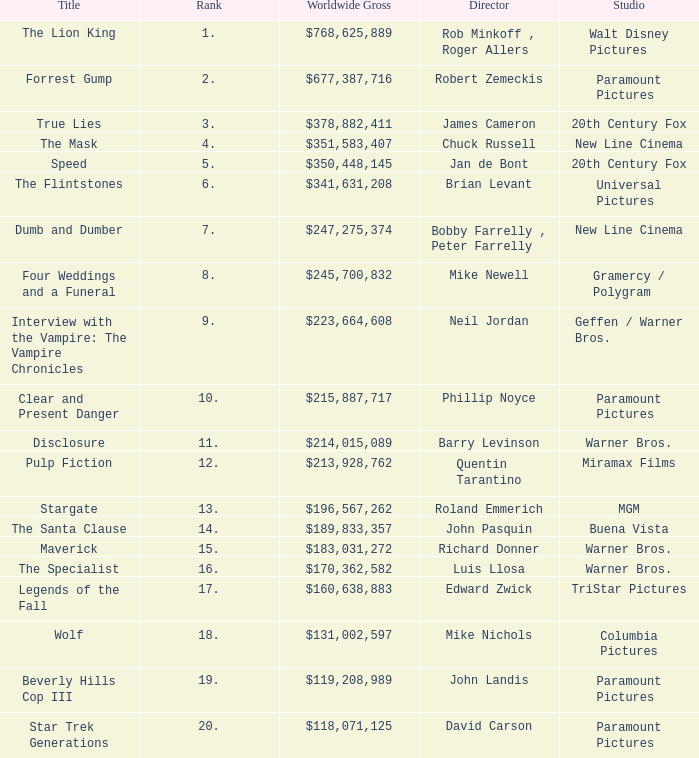Could you parse the entire table as a dict? {'header': ['Title', 'Rank', 'Worldwide Gross', 'Director', 'Studio'], 'rows': [['The Lion King', '1.', '$768,625,889', 'Rob Minkoff , Roger Allers', 'Walt Disney Pictures'], ['Forrest Gump', '2.', '$677,387,716', 'Robert Zemeckis', 'Paramount Pictures'], ['True Lies', '3.', '$378,882,411', 'James Cameron', '20th Century Fox'], ['The Mask', '4.', '$351,583,407', 'Chuck Russell', 'New Line Cinema'], ['Speed', '5.', '$350,448,145', 'Jan de Bont', '20th Century Fox'], ['The Flintstones', '6.', '$341,631,208', 'Brian Levant', 'Universal Pictures'], ['Dumb and Dumber', '7.', '$247,275,374', 'Bobby Farrelly , Peter Farrelly', 'New Line Cinema'], ['Four Weddings and a Funeral', '8.', '$245,700,832', 'Mike Newell', 'Gramercy / Polygram'], ['Interview with the Vampire: The Vampire Chronicles', '9.', '$223,664,608', 'Neil Jordan', 'Geffen / Warner Bros.'], ['Clear and Present Danger', '10.', '$215,887,717', 'Phillip Noyce', 'Paramount Pictures'], ['Disclosure', '11.', '$214,015,089', 'Barry Levinson', 'Warner Bros.'], ['Pulp Fiction', '12.', '$213,928,762', 'Quentin Tarantino', 'Miramax Films'], ['Stargate', '13.', '$196,567,262', 'Roland Emmerich', 'MGM'], ['The Santa Clause', '14.', '$189,833,357', 'John Pasquin', 'Buena Vista'], ['Maverick', '15.', '$183,031,272', 'Richard Donner', 'Warner Bros.'], ['The Specialist', '16.', '$170,362,582', 'Luis Llosa', 'Warner Bros.'], ['Legends of the Fall', '17.', '$160,638,883', 'Edward Zwick', 'TriStar Pictures'], ['Wolf', '18.', '$131,002,597', 'Mike Nichols', 'Columbia Pictures'], ['Beverly Hills Cop III', '19.', '$119,208,989', 'John Landis', 'Paramount Pictures'], ['Star Trek Generations', '20.', '$118,071,125', 'David Carson', 'Paramount Pictures']]} What is the Rank of the Film with a Worldwide Gross of $183,031,272? 15.0. 